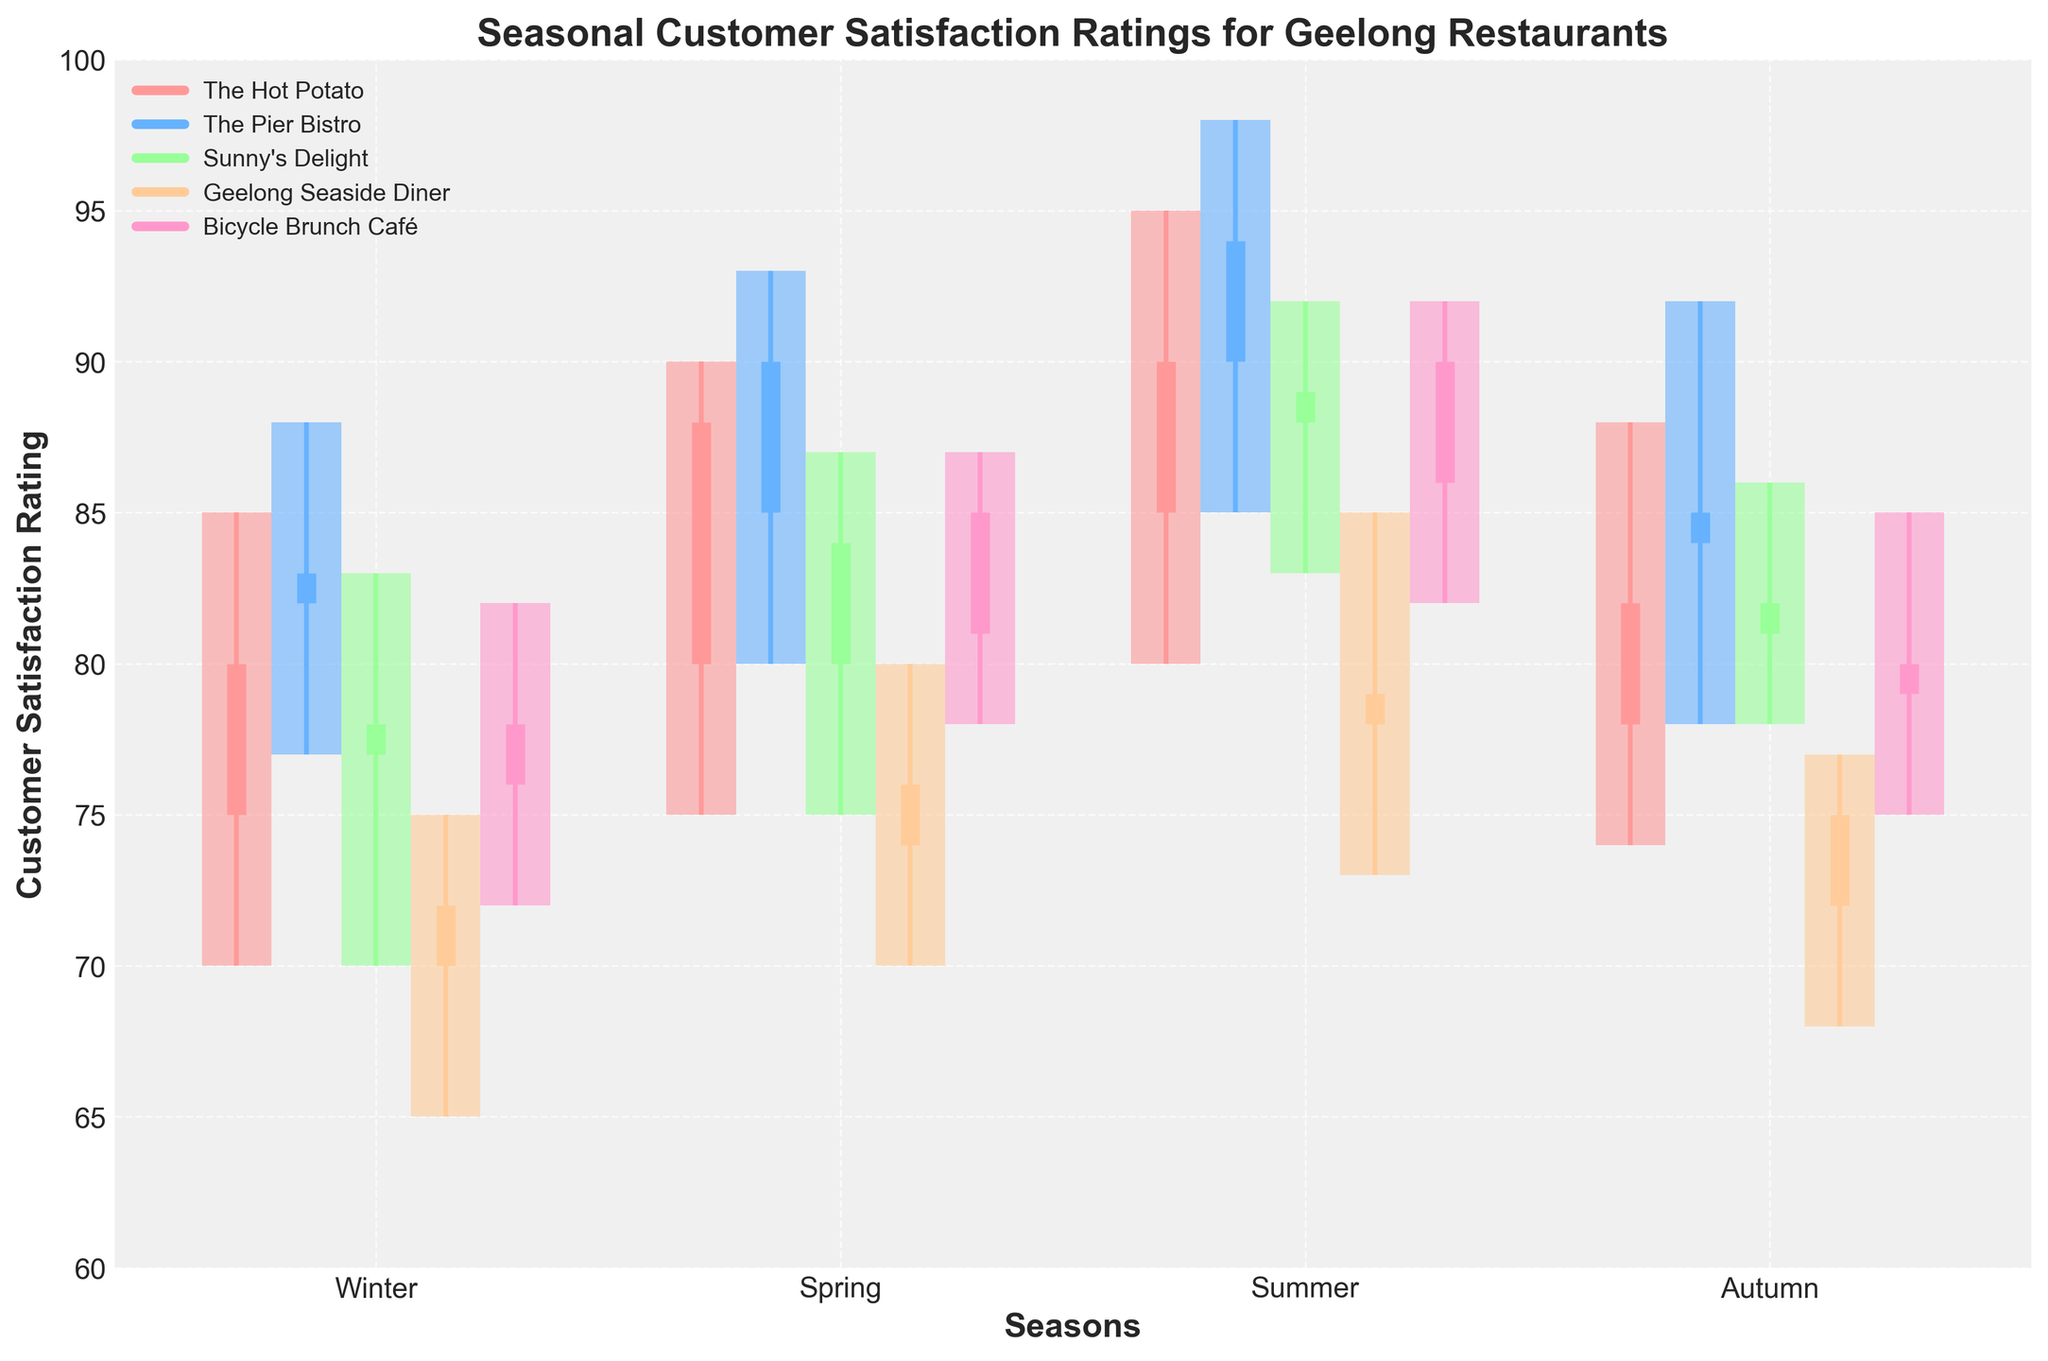What is the title of the plot? The title is prominently displayed at the top of the plot. It reads "Seasonal Customer Satisfaction Ratings for Geelong Restaurants."
Answer: Seasonal Customer Satisfaction Ratings for Geelong Restaurants Which season has the highest customer satisfaction rating for The Pier Bistro? For The Pier Bistro, the bars and lines representing the highest values are in the Summer season. The highest point on the candlestick for The Pier Bistro in Summer is 98.
Answer: Summer How many restaurants are compared in the plot? By counting the different colors and the legend entries, we can see that there are five restaurants being compared in the plot.
Answer: Five What is the range of customer satisfaction ratings for Sunny's Delight in Winter? The range is found by subtracting the lowest point (70) from the highest point (83) for Sunny's Delight in Winter. The range is 83 - 70.
Answer: 13 Which restaurant shows the most increase in customer satisfaction from Winter to Spring? By observing the candlesticks from Winter to Spring for each restaurant, The Hot Potato shows an increase from 80 (close in Winter) to 88 (close in Spring), which is the highest observed increase.
Answer: The Hot Potato In which season does Bicycle Brunch Café have the highest customer satisfaction rating? The highest point on the candlestick plot for Bicycle Brunch Café corresponds to the Summer season, which is 92.
Answer: Summer What is the average customer satisfaction rating for Geelong Seaside Diner in Autumn? The average is calculated by summing the open (72), high (77), low (68), and close (75) values and dividing by 4. (72 + 77 + 68 + 75) / 4 = 73.
Answer: 73 Compare the customer satisfaction rating ranges between Spring and Summer for The Hot Potato. Which season has a wider range? For The Hot Potato, in Spring the range is 90 - 75 = 15, and in Summer, it is 95 - 80 = 15. Both seasons have the same range.
Answer: Both have the same range How does the median customer satisfaction rating of Winter compare across all restaurants? To find the median of the Winter satisfaction ratings for all restaurants: The values are 80, 83, 78, 72, and 78. Ordering these values gives 72, 78, 78, 80, 83. The median value is 78.
Answer: 78 